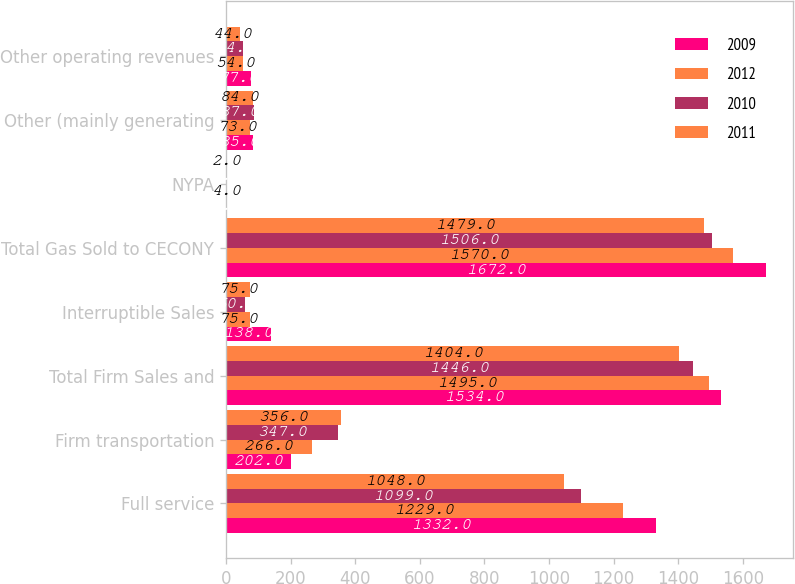Convert chart to OTSL. <chart><loc_0><loc_0><loc_500><loc_500><stacked_bar_chart><ecel><fcel>Full service<fcel>Firm transportation<fcel>Total Firm Sales and<fcel>Interruptible Sales<fcel>Total Gas Sold to CECONY<fcel>NYPA<fcel>Other (mainly generating<fcel>Other operating revenues<nl><fcel>2009<fcel>1332<fcel>202<fcel>1534<fcel>138<fcel>1672<fcel>4<fcel>85<fcel>77<nl><fcel>2012<fcel>1229<fcel>266<fcel>1495<fcel>75<fcel>1570<fcel>4<fcel>73<fcel>54<nl><fcel>2010<fcel>1099<fcel>347<fcel>1446<fcel>60<fcel>1506<fcel>2<fcel>87<fcel>54<nl><fcel>2011<fcel>1048<fcel>356<fcel>1404<fcel>75<fcel>1479<fcel>2<fcel>84<fcel>44<nl></chart> 